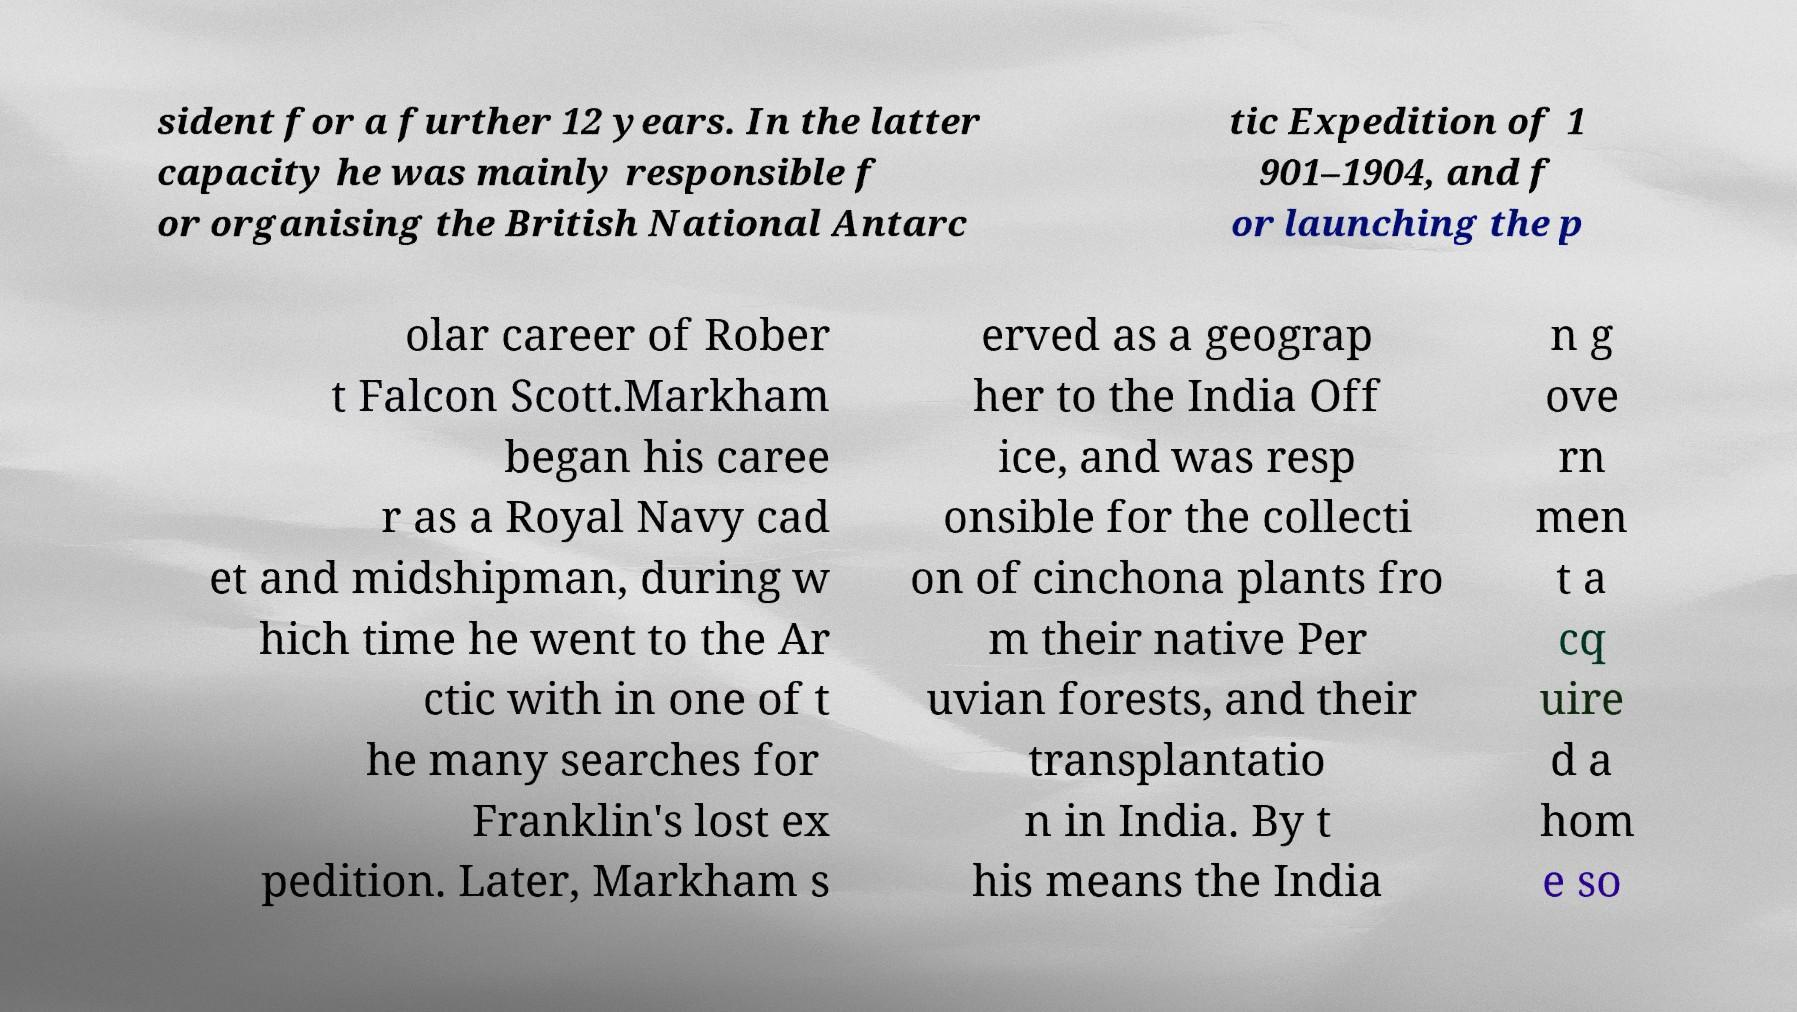What messages or text are displayed in this image? I need them in a readable, typed format. sident for a further 12 years. In the latter capacity he was mainly responsible f or organising the British National Antarc tic Expedition of 1 901–1904, and f or launching the p olar career of Rober t Falcon Scott.Markham began his caree r as a Royal Navy cad et and midshipman, during w hich time he went to the Ar ctic with in one of t he many searches for Franklin's lost ex pedition. Later, Markham s erved as a geograp her to the India Off ice, and was resp onsible for the collecti on of cinchona plants fro m their native Per uvian forests, and their transplantatio n in India. By t his means the India n g ove rn men t a cq uire d a hom e so 